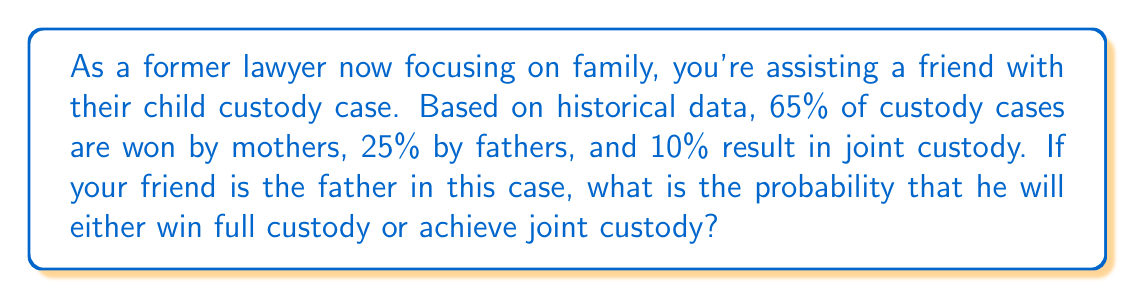Help me with this question. Let's approach this step-by-step:

1) We're given the following probabilities:
   - P(Mother wins) = 65% = 0.65
   - P(Father wins) = 25% = 0.25
   - P(Joint custody) = 10% = 0.10

2) We need to find the probability of the father either winning full custody or achieving joint custody. This is a case of the addition rule of probability, as these are mutually exclusive events.

3) Let's define the events:
   A = Father wins full custody
   B = Joint custody is achieved

4) We want to calculate P(A or B), which is equivalent to P(A) + P(B)

5) We already know these probabilities from the given data:
   P(A) = 0.25
   P(B) = 0.10

6) Therefore, the probability we're looking for is:

   $$P(A \text{ or } B) = P(A) + P(B) = 0.25 + 0.10 = 0.35$$

7) Converting to a percentage:

   $$0.35 \times 100\% = 35\%$$

Thus, the probability that the father will either win full custody or achieve joint custody is 35%.
Answer: 35% 